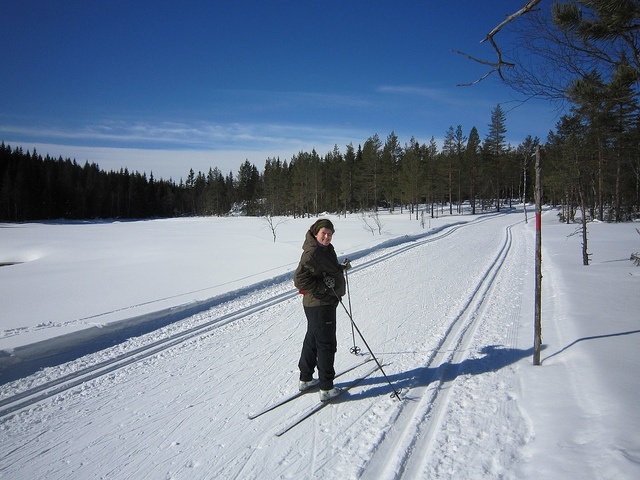Describe the objects in this image and their specific colors. I can see people in navy, black, gray, and lightgray tones and skis in navy, lightgray, and darkgray tones in this image. 